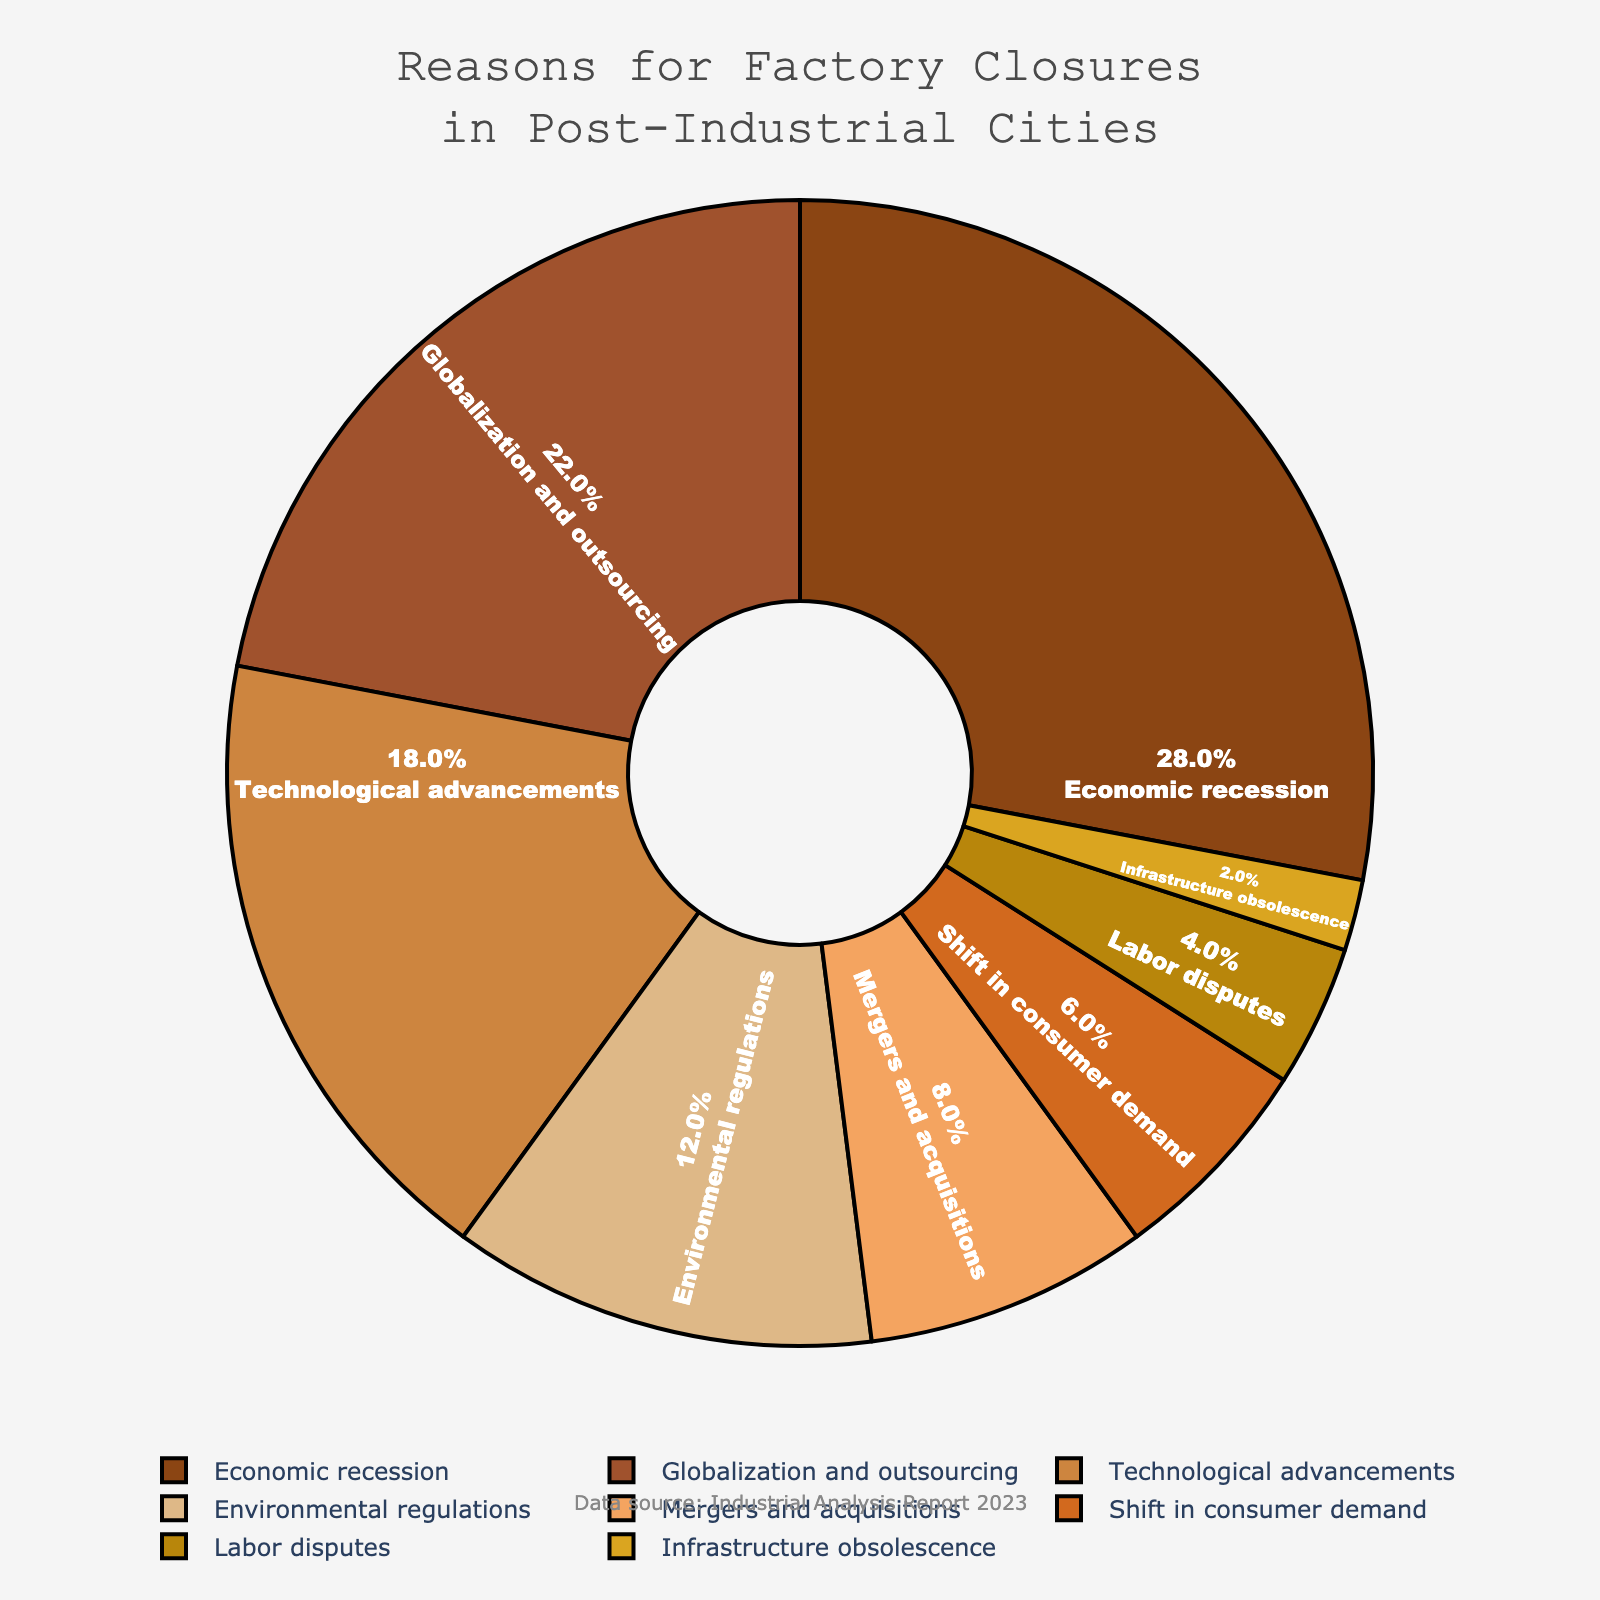What's the biggest reason for factory closures depicted in the pie chart? The largest wedge in the pie chart represents the biggest reason for factory closures. This wedge is labeled as "Economic recession" and occupies the largest portion of the chart.
Answer: Economic recession What's the combined percentage of factory closures due to Economic recession and Globalization and outsourcing? The percentage for Economic recession is 28%, and for Globalization and outsourcing, it is 22%. Adding these two values gives 28% + 22% = 50%.
Answer: 50% Which reason accounts for a smaller percentage of factory closures: Environmental regulations or Labor disputes? By analyzing the pie chart, we see that Environmental regulations account for 12% of closures, whereas Labor disputes account for 4%. Since 4% is smaller than 12%, Labor disputes account for a smaller percentage.
Answer: Labor disputes What is the difference between the percentages of factory closures due to Technological advancements and Shift in consumer demand? The percentage for Technological advancements is 18%, and for Shift in consumer demand, it is 6%. The difference between these two values is 18% - 6% = 12%.
Answer: 12% Which three reasons contribute equally to the factory closures based on their color representations? Examining the color representations of the pie chart, we can see that there are no three reasons with exactly equal percentages. However, each reason has unique colors as per the legend.
Answer: None What proportion of factory closures is due to factors with percentages below 10%? Factors with percentages below 10% include Mergers and acquisitions (8%), Shift in consumer demand (6%), Labor disputes (4%), and Infrastructure obsolescence (2%). Adding these values gives 8% + 6% + 4% + 2% = 20%.
Answer: 20% What is the combined share of factory closures due to Technological advancements and Environmental regulations? Summing the percentages for Technological advancements (18%) and Environmental regulations (12%), we get 18% + 12% = 30%.
Answer: 30% Considering Mergers and acquisitions and Infrastructure obsolescence, which one has a higher percentage of factory closures and by how much? Mergers and acquisitions account for 8% of factory closures, while Infrastructure obsolescence accounts for 2%. The difference is 8% - 2% = 6%.
Answer: Mergers and acquisitions by 6% How does the percentage for Shift in consumer demand compare to Labor disputes? Shift in consumer demand is 6%, and Labor disputes is 4%. Comparing these, Shift in consumer demand is larger.
Answer: Shift in consumer demand What's the sum of the percentages of factory closures for the two reasons with the least amount of impact? The reasons with the least impact are Labor disputes (4%) and Infrastructure obsolescence (2%). Summing these gives 4% + 2% = 6%.
Answer: 6% 